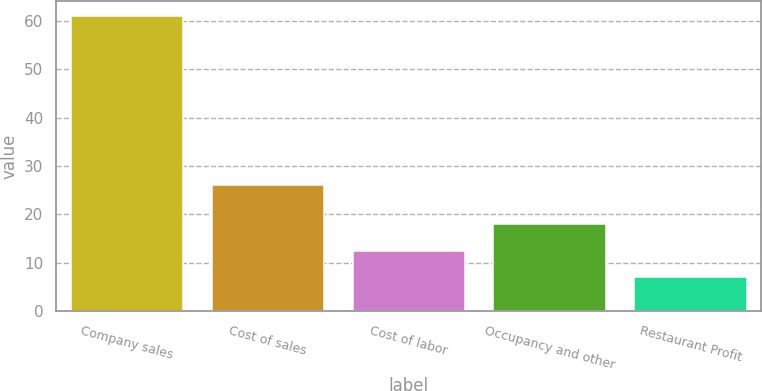Convert chart to OTSL. <chart><loc_0><loc_0><loc_500><loc_500><bar_chart><fcel>Company sales<fcel>Cost of sales<fcel>Cost of labor<fcel>Occupancy and other<fcel>Restaurant Profit<nl><fcel>61<fcel>26<fcel>12.4<fcel>18<fcel>7<nl></chart> 